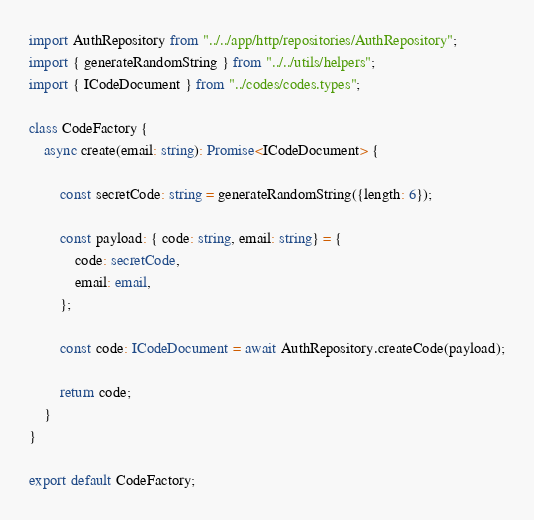<code> <loc_0><loc_0><loc_500><loc_500><_TypeScript_>import AuthRepository from "../../app/http/repositories/AuthRepository";
import { generateRandomString } from "../../utils/helpers";
import { ICodeDocument } from "../codes/codes.types";

class CodeFactory {
    async create(email: string): Promise<ICodeDocument> {

        const secretCode: string = generateRandomString({length: 6});

        const payload: { code: string, email: string} = {
            code: secretCode,
            email: email,
        };

        const code: ICodeDocument = await AuthRepository.createCode(payload);

        return code;
    }
}

export default CodeFactory;
</code> 